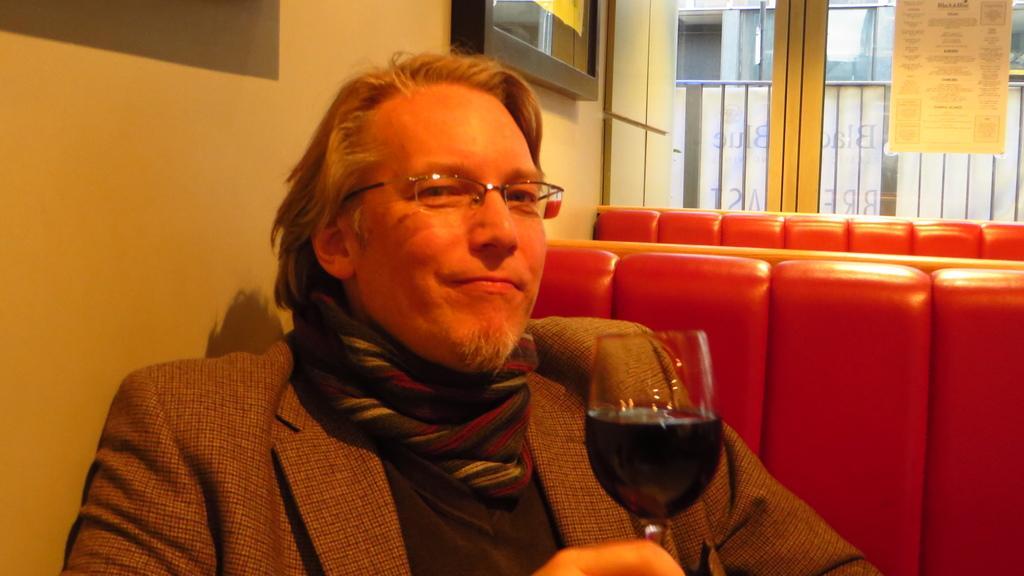Can you describe this image briefly? He is a person sitting on a chair. He is wearing a suit and he is holding a glass of wine in his right hand. 